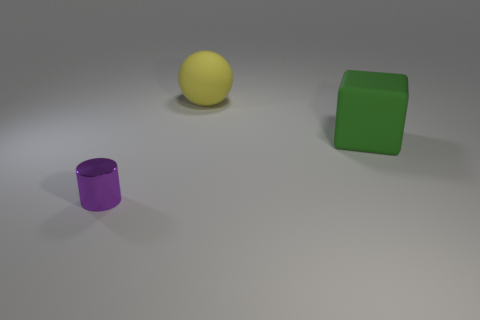Are the large thing to the left of the cube and the thing that is in front of the green block made of the same material?
Keep it short and to the point. No. The thing that is the same size as the yellow matte sphere is what shape?
Your answer should be compact. Cube. Is the number of blue cylinders less than the number of yellow things?
Keep it short and to the point. Yes. There is a large rubber object that is behind the large green object; is there a yellow sphere that is left of it?
Your response must be concise. No. There is a big green object to the right of the matte object on the left side of the big green matte cube; is there a big green block left of it?
Offer a very short reply. No. There is a large thing on the left side of the green thing; is its shape the same as the thing that is right of the big matte ball?
Provide a short and direct response. No. There is another large object that is the same material as the big green thing; what is its color?
Your answer should be compact. Yellow. Is the number of tiny metal cylinders that are on the right side of the green rubber cube less than the number of tiny purple objects?
Give a very brief answer. Yes. What is the size of the thing that is behind the matte thing in front of the rubber thing behind the green matte block?
Your response must be concise. Large. Are the thing that is behind the large matte cube and the green block made of the same material?
Offer a terse response. Yes. 